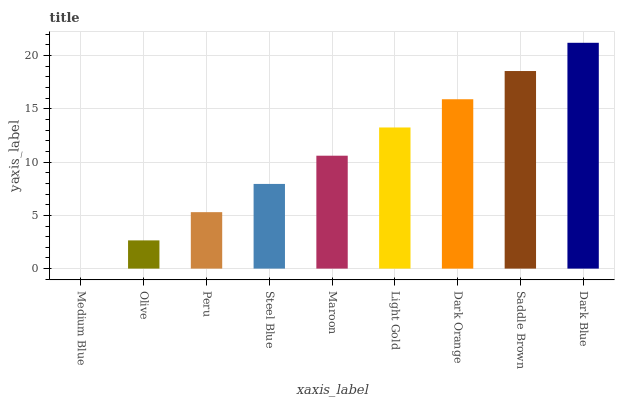Is Medium Blue the minimum?
Answer yes or no. Yes. Is Dark Blue the maximum?
Answer yes or no. Yes. Is Olive the minimum?
Answer yes or no. No. Is Olive the maximum?
Answer yes or no. No. Is Olive greater than Medium Blue?
Answer yes or no. Yes. Is Medium Blue less than Olive?
Answer yes or no. Yes. Is Medium Blue greater than Olive?
Answer yes or no. No. Is Olive less than Medium Blue?
Answer yes or no. No. Is Maroon the high median?
Answer yes or no. Yes. Is Maroon the low median?
Answer yes or no. Yes. Is Dark Blue the high median?
Answer yes or no. No. Is Medium Blue the low median?
Answer yes or no. No. 